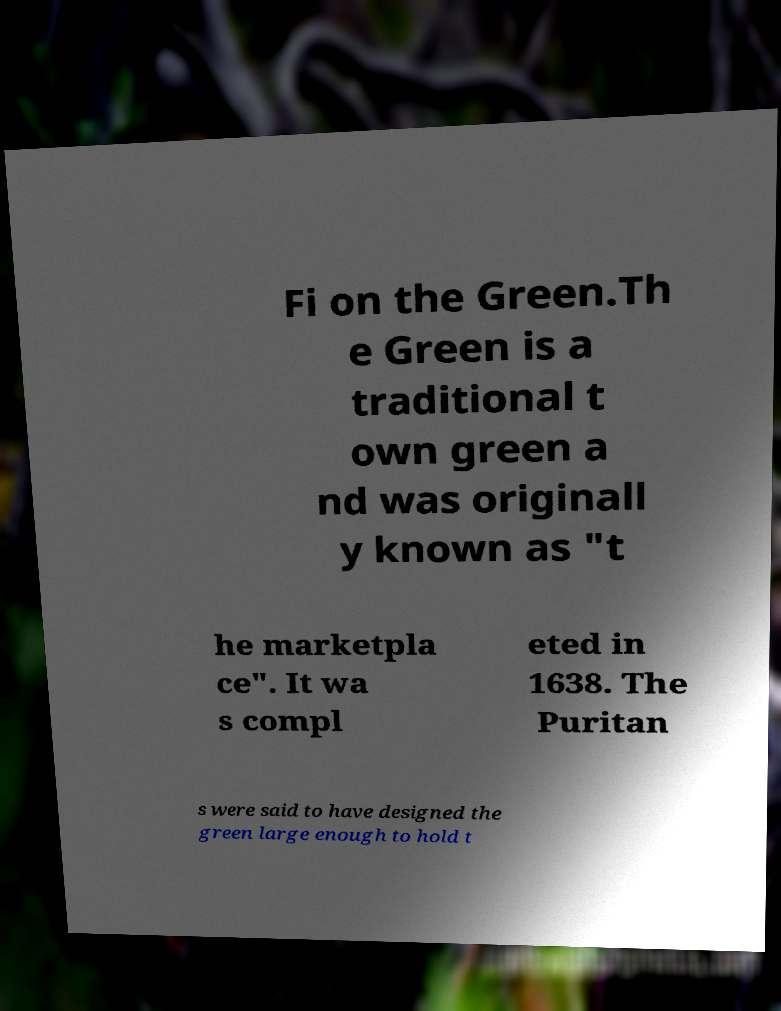Can you read and provide the text displayed in the image?This photo seems to have some interesting text. Can you extract and type it out for me? Fi on the Green.Th e Green is a traditional t own green a nd was originall y known as "t he marketpla ce". It wa s compl eted in 1638. The Puritan s were said to have designed the green large enough to hold t 